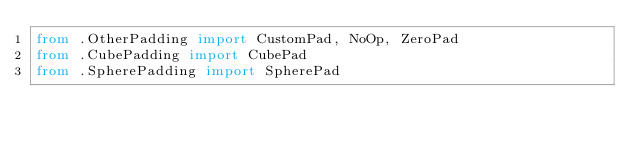Convert code to text. <code><loc_0><loc_0><loc_500><loc_500><_Python_>from .OtherPadding import CustomPad, NoOp, ZeroPad
from .CubePadding import CubePad
from .SpherePadding import SpherePad
</code> 